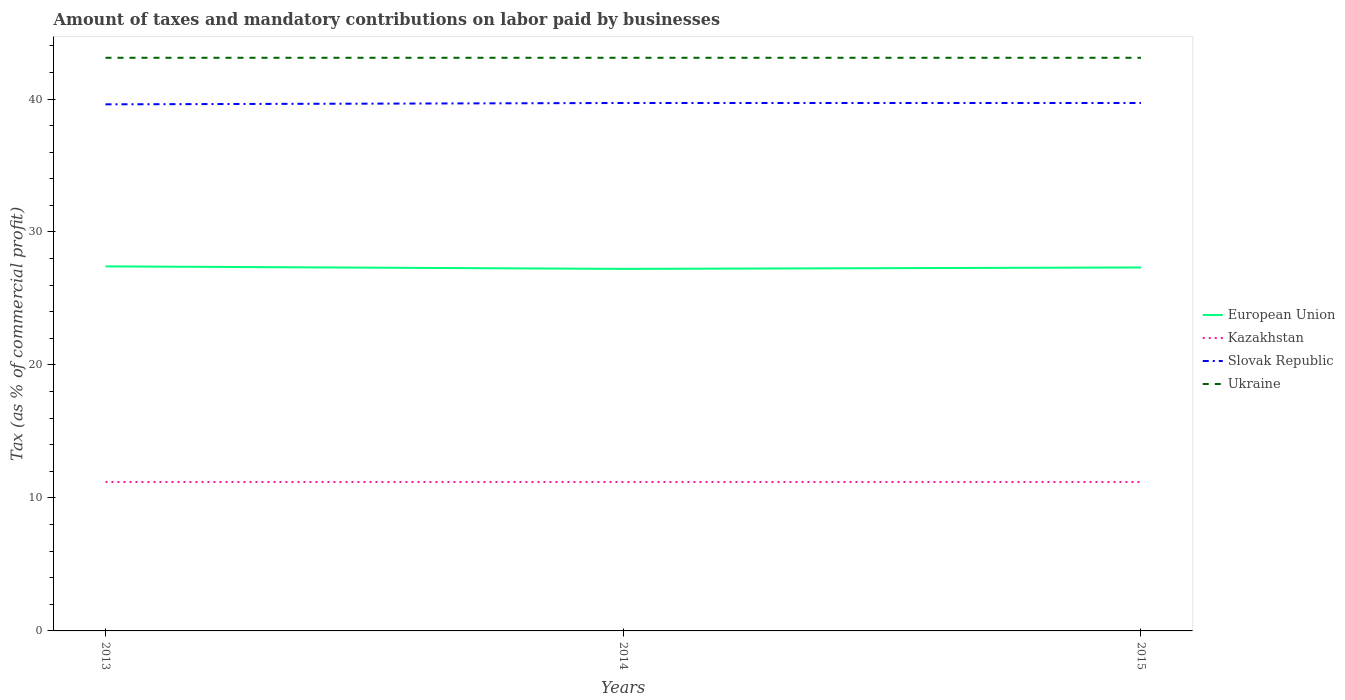Does the line corresponding to Kazakhstan intersect with the line corresponding to Slovak Republic?
Provide a short and direct response. No. Is the number of lines equal to the number of legend labels?
Provide a succinct answer. Yes. Across all years, what is the maximum percentage of taxes paid by businesses in Slovak Republic?
Your response must be concise. 39.6. In which year was the percentage of taxes paid by businesses in Slovak Republic maximum?
Provide a succinct answer. 2013. What is the difference between the highest and the second highest percentage of taxes paid by businesses in Kazakhstan?
Your response must be concise. 0. Is the percentage of taxes paid by businesses in Kazakhstan strictly greater than the percentage of taxes paid by businesses in Ukraine over the years?
Keep it short and to the point. Yes. What is the difference between two consecutive major ticks on the Y-axis?
Make the answer very short. 10. Are the values on the major ticks of Y-axis written in scientific E-notation?
Your response must be concise. No. Does the graph contain any zero values?
Keep it short and to the point. No. Does the graph contain grids?
Keep it short and to the point. No. What is the title of the graph?
Your answer should be very brief. Amount of taxes and mandatory contributions on labor paid by businesses. Does "Vietnam" appear as one of the legend labels in the graph?
Provide a short and direct response. No. What is the label or title of the X-axis?
Offer a very short reply. Years. What is the label or title of the Y-axis?
Provide a short and direct response. Tax (as % of commercial profit). What is the Tax (as % of commercial profit) in European Union in 2013?
Keep it short and to the point. 27.41. What is the Tax (as % of commercial profit) of Slovak Republic in 2013?
Provide a succinct answer. 39.6. What is the Tax (as % of commercial profit) of Ukraine in 2013?
Provide a short and direct response. 43.1. What is the Tax (as % of commercial profit) of European Union in 2014?
Your answer should be very brief. 27.23. What is the Tax (as % of commercial profit) of Slovak Republic in 2014?
Provide a short and direct response. 39.7. What is the Tax (as % of commercial profit) of Ukraine in 2014?
Offer a very short reply. 43.1. What is the Tax (as % of commercial profit) in European Union in 2015?
Ensure brevity in your answer.  27.33. What is the Tax (as % of commercial profit) of Slovak Republic in 2015?
Offer a very short reply. 39.7. What is the Tax (as % of commercial profit) of Ukraine in 2015?
Give a very brief answer. 43.1. Across all years, what is the maximum Tax (as % of commercial profit) of European Union?
Make the answer very short. 27.41. Across all years, what is the maximum Tax (as % of commercial profit) of Slovak Republic?
Provide a short and direct response. 39.7. Across all years, what is the maximum Tax (as % of commercial profit) in Ukraine?
Provide a succinct answer. 43.1. Across all years, what is the minimum Tax (as % of commercial profit) in European Union?
Make the answer very short. 27.23. Across all years, what is the minimum Tax (as % of commercial profit) in Kazakhstan?
Your response must be concise. 11.2. Across all years, what is the minimum Tax (as % of commercial profit) in Slovak Republic?
Provide a succinct answer. 39.6. Across all years, what is the minimum Tax (as % of commercial profit) of Ukraine?
Ensure brevity in your answer.  43.1. What is the total Tax (as % of commercial profit) of European Union in the graph?
Provide a short and direct response. 81.97. What is the total Tax (as % of commercial profit) of Kazakhstan in the graph?
Provide a short and direct response. 33.6. What is the total Tax (as % of commercial profit) in Slovak Republic in the graph?
Give a very brief answer. 119. What is the total Tax (as % of commercial profit) of Ukraine in the graph?
Give a very brief answer. 129.3. What is the difference between the Tax (as % of commercial profit) of European Union in 2013 and that in 2014?
Provide a short and direct response. 0.19. What is the difference between the Tax (as % of commercial profit) of Ukraine in 2013 and that in 2014?
Offer a very short reply. 0. What is the difference between the Tax (as % of commercial profit) of European Union in 2013 and that in 2015?
Keep it short and to the point. 0.08. What is the difference between the Tax (as % of commercial profit) in Slovak Republic in 2013 and that in 2015?
Your answer should be compact. -0.1. What is the difference between the Tax (as % of commercial profit) in European Union in 2014 and that in 2015?
Your answer should be compact. -0.11. What is the difference between the Tax (as % of commercial profit) in Kazakhstan in 2014 and that in 2015?
Make the answer very short. 0. What is the difference between the Tax (as % of commercial profit) in Ukraine in 2014 and that in 2015?
Keep it short and to the point. 0. What is the difference between the Tax (as % of commercial profit) in European Union in 2013 and the Tax (as % of commercial profit) in Kazakhstan in 2014?
Offer a terse response. 16.21. What is the difference between the Tax (as % of commercial profit) of European Union in 2013 and the Tax (as % of commercial profit) of Slovak Republic in 2014?
Make the answer very short. -12.29. What is the difference between the Tax (as % of commercial profit) of European Union in 2013 and the Tax (as % of commercial profit) of Ukraine in 2014?
Your response must be concise. -15.69. What is the difference between the Tax (as % of commercial profit) of Kazakhstan in 2013 and the Tax (as % of commercial profit) of Slovak Republic in 2014?
Your answer should be compact. -28.5. What is the difference between the Tax (as % of commercial profit) of Kazakhstan in 2013 and the Tax (as % of commercial profit) of Ukraine in 2014?
Offer a terse response. -31.9. What is the difference between the Tax (as % of commercial profit) in Slovak Republic in 2013 and the Tax (as % of commercial profit) in Ukraine in 2014?
Ensure brevity in your answer.  -3.5. What is the difference between the Tax (as % of commercial profit) in European Union in 2013 and the Tax (as % of commercial profit) in Kazakhstan in 2015?
Make the answer very short. 16.21. What is the difference between the Tax (as % of commercial profit) in European Union in 2013 and the Tax (as % of commercial profit) in Slovak Republic in 2015?
Provide a succinct answer. -12.29. What is the difference between the Tax (as % of commercial profit) in European Union in 2013 and the Tax (as % of commercial profit) in Ukraine in 2015?
Provide a succinct answer. -15.69. What is the difference between the Tax (as % of commercial profit) of Kazakhstan in 2013 and the Tax (as % of commercial profit) of Slovak Republic in 2015?
Offer a very short reply. -28.5. What is the difference between the Tax (as % of commercial profit) of Kazakhstan in 2013 and the Tax (as % of commercial profit) of Ukraine in 2015?
Your answer should be compact. -31.9. What is the difference between the Tax (as % of commercial profit) in European Union in 2014 and the Tax (as % of commercial profit) in Kazakhstan in 2015?
Make the answer very short. 16.02. What is the difference between the Tax (as % of commercial profit) of European Union in 2014 and the Tax (as % of commercial profit) of Slovak Republic in 2015?
Make the answer very short. -12.47. What is the difference between the Tax (as % of commercial profit) of European Union in 2014 and the Tax (as % of commercial profit) of Ukraine in 2015?
Offer a very short reply. -15.88. What is the difference between the Tax (as % of commercial profit) in Kazakhstan in 2014 and the Tax (as % of commercial profit) in Slovak Republic in 2015?
Your answer should be very brief. -28.5. What is the difference between the Tax (as % of commercial profit) of Kazakhstan in 2014 and the Tax (as % of commercial profit) of Ukraine in 2015?
Your response must be concise. -31.9. What is the average Tax (as % of commercial profit) in European Union per year?
Keep it short and to the point. 27.32. What is the average Tax (as % of commercial profit) in Slovak Republic per year?
Your answer should be very brief. 39.67. What is the average Tax (as % of commercial profit) of Ukraine per year?
Your answer should be very brief. 43.1. In the year 2013, what is the difference between the Tax (as % of commercial profit) of European Union and Tax (as % of commercial profit) of Kazakhstan?
Your answer should be very brief. 16.21. In the year 2013, what is the difference between the Tax (as % of commercial profit) of European Union and Tax (as % of commercial profit) of Slovak Republic?
Keep it short and to the point. -12.19. In the year 2013, what is the difference between the Tax (as % of commercial profit) of European Union and Tax (as % of commercial profit) of Ukraine?
Your answer should be very brief. -15.69. In the year 2013, what is the difference between the Tax (as % of commercial profit) in Kazakhstan and Tax (as % of commercial profit) in Slovak Republic?
Provide a short and direct response. -28.4. In the year 2013, what is the difference between the Tax (as % of commercial profit) of Kazakhstan and Tax (as % of commercial profit) of Ukraine?
Keep it short and to the point. -31.9. In the year 2013, what is the difference between the Tax (as % of commercial profit) in Slovak Republic and Tax (as % of commercial profit) in Ukraine?
Offer a terse response. -3.5. In the year 2014, what is the difference between the Tax (as % of commercial profit) in European Union and Tax (as % of commercial profit) in Kazakhstan?
Your response must be concise. 16.02. In the year 2014, what is the difference between the Tax (as % of commercial profit) in European Union and Tax (as % of commercial profit) in Slovak Republic?
Provide a succinct answer. -12.47. In the year 2014, what is the difference between the Tax (as % of commercial profit) of European Union and Tax (as % of commercial profit) of Ukraine?
Make the answer very short. -15.88. In the year 2014, what is the difference between the Tax (as % of commercial profit) in Kazakhstan and Tax (as % of commercial profit) in Slovak Republic?
Your answer should be very brief. -28.5. In the year 2014, what is the difference between the Tax (as % of commercial profit) of Kazakhstan and Tax (as % of commercial profit) of Ukraine?
Offer a terse response. -31.9. In the year 2015, what is the difference between the Tax (as % of commercial profit) in European Union and Tax (as % of commercial profit) in Kazakhstan?
Your answer should be very brief. 16.13. In the year 2015, what is the difference between the Tax (as % of commercial profit) in European Union and Tax (as % of commercial profit) in Slovak Republic?
Ensure brevity in your answer.  -12.37. In the year 2015, what is the difference between the Tax (as % of commercial profit) of European Union and Tax (as % of commercial profit) of Ukraine?
Your response must be concise. -15.77. In the year 2015, what is the difference between the Tax (as % of commercial profit) of Kazakhstan and Tax (as % of commercial profit) of Slovak Republic?
Your response must be concise. -28.5. In the year 2015, what is the difference between the Tax (as % of commercial profit) of Kazakhstan and Tax (as % of commercial profit) of Ukraine?
Ensure brevity in your answer.  -31.9. In the year 2015, what is the difference between the Tax (as % of commercial profit) of Slovak Republic and Tax (as % of commercial profit) of Ukraine?
Provide a succinct answer. -3.4. What is the ratio of the Tax (as % of commercial profit) of European Union in 2013 to that in 2014?
Give a very brief answer. 1.01. What is the ratio of the Tax (as % of commercial profit) in European Union in 2013 to that in 2015?
Your answer should be very brief. 1. What is the ratio of the Tax (as % of commercial profit) in Kazakhstan in 2013 to that in 2015?
Offer a terse response. 1. What is the ratio of the Tax (as % of commercial profit) in Ukraine in 2013 to that in 2015?
Ensure brevity in your answer.  1. What is the ratio of the Tax (as % of commercial profit) in European Union in 2014 to that in 2015?
Make the answer very short. 1. What is the ratio of the Tax (as % of commercial profit) in Slovak Republic in 2014 to that in 2015?
Your answer should be very brief. 1. What is the ratio of the Tax (as % of commercial profit) of Ukraine in 2014 to that in 2015?
Offer a terse response. 1. What is the difference between the highest and the second highest Tax (as % of commercial profit) of European Union?
Ensure brevity in your answer.  0.08. What is the difference between the highest and the second highest Tax (as % of commercial profit) in Kazakhstan?
Ensure brevity in your answer.  0. What is the difference between the highest and the lowest Tax (as % of commercial profit) in European Union?
Your answer should be very brief. 0.19. What is the difference between the highest and the lowest Tax (as % of commercial profit) of Ukraine?
Make the answer very short. 0. 